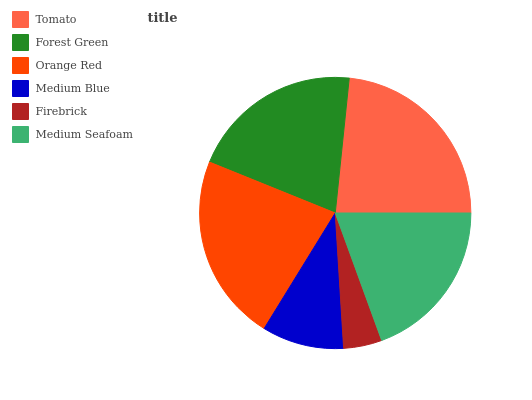Is Firebrick the minimum?
Answer yes or no. Yes. Is Tomato the maximum?
Answer yes or no. Yes. Is Forest Green the minimum?
Answer yes or no. No. Is Forest Green the maximum?
Answer yes or no. No. Is Tomato greater than Forest Green?
Answer yes or no. Yes. Is Forest Green less than Tomato?
Answer yes or no. Yes. Is Forest Green greater than Tomato?
Answer yes or no. No. Is Tomato less than Forest Green?
Answer yes or no. No. Is Forest Green the high median?
Answer yes or no. Yes. Is Medium Seafoam the low median?
Answer yes or no. Yes. Is Tomato the high median?
Answer yes or no. No. Is Firebrick the low median?
Answer yes or no. No. 